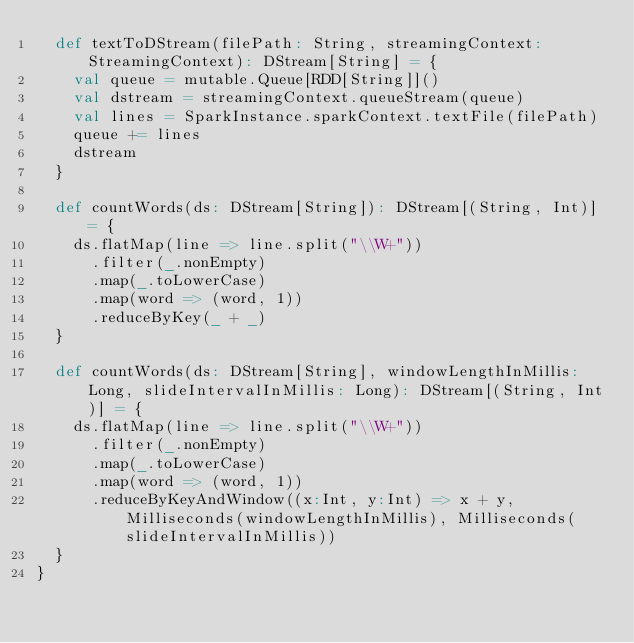<code> <loc_0><loc_0><loc_500><loc_500><_Scala_>  def textToDStream(filePath: String, streamingContext: StreamingContext): DStream[String] = {
    val queue = mutable.Queue[RDD[String]]()
    val dstream = streamingContext.queueStream(queue)
    val lines = SparkInstance.sparkContext.textFile(filePath)
    queue += lines
    dstream
  }

  def countWords(ds: DStream[String]): DStream[(String, Int)] = {
    ds.flatMap(line => line.split("\\W+"))
      .filter(_.nonEmpty)
      .map(_.toLowerCase)
      .map(word => (word, 1))
      .reduceByKey(_ + _)
  }

  def countWords(ds: DStream[String], windowLengthInMillis: Long, slideIntervalInMillis: Long): DStream[(String, Int)] = {
    ds.flatMap(line => line.split("\\W+"))
      .filter(_.nonEmpty)
      .map(_.toLowerCase)
      .map(word => (word, 1))
      .reduceByKeyAndWindow((x:Int, y:Int) => x + y, Milliseconds(windowLengthInMillis), Milliseconds(slideIntervalInMillis))
  }
}</code> 